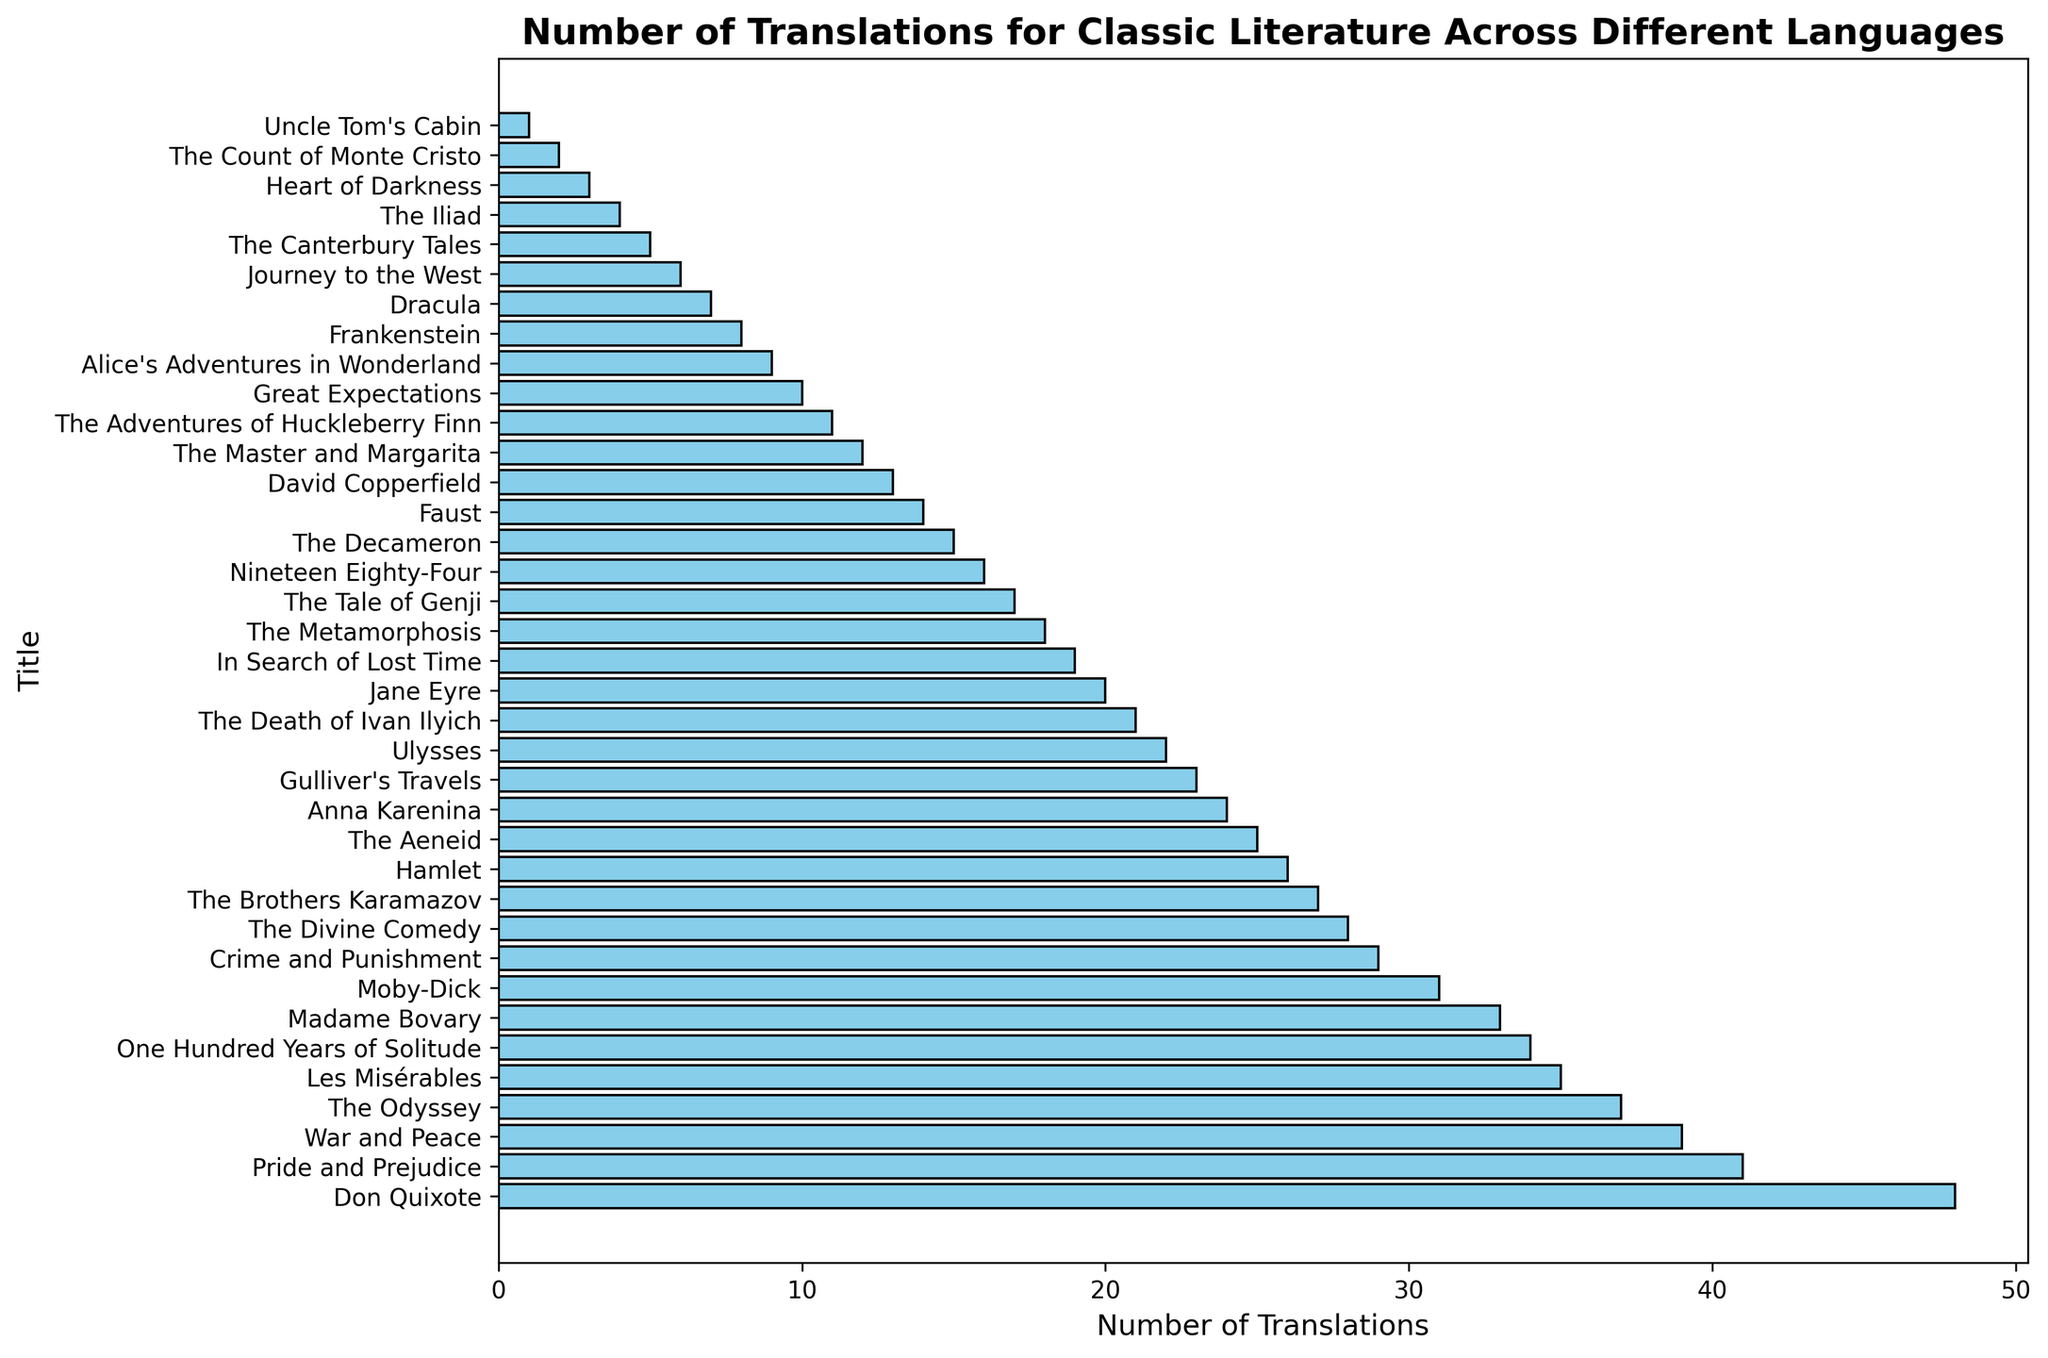What is the title with the highest number of translations? Identify the bar with the greatest length, as it represents the highest quantity. This bar corresponds to "Don Quixote".
Answer: "Don Quixote" Which language has the most titles translated more than 30 times? Check the languages of titles that appear on the top part of the histogram. Spanish has "Don Quixote" and "One Hundred Years of Solitude", while English has "Pride and Prejudice" and "Moby-Dick". Spanish and English each have two titles.
Answer: Spanish and English What is the total number of translations for the French titles in the dataset? Sum the number of translations for all French titles: "Les Misérables" (35), "Madame Bovary" (33), "In Search of Lost Time" (19), and "The Count of Monte Cristo" (2). 35 + 33 + 19 + 2 = 89
Answer: 89 Which two titles have a difference of exactly two translations between them? Examine the histogram for pairs of bars where the difference in length corresponds to a difference of two in translations. "The Odyssey" (37) and "Les Misérables" (35) match this criterion.
Answer: "The Odyssey" and "Les Misérables" How many titles have fewer than 10 translations? Count the number of bars that are shorter than the tick mark for 10 translations. Titles with fewer than 10 translations include "Journey to the West", "The Canterbury Tales", "The Iliad", "Heart of Darkness", "The Count of Monte Cristo", and "Uncle Tom's Cabin". There are 6 such titles.
Answer: 6 What is the average number of translations for English titles? Compute the average by summing the translations for English titles and dividing by the number of English titles: (41 + 31 + 26 + 23 + 22 + 20 + 16 + 13 + 11 + 10 + 9 + 8 + 7 + 5 + 3 + 1) / 16 = 13.875.
Answer: 13.875 Which title has the second highest number of translations? The second longest bar after "Don Quixote" represents the title with the second highest number of translations, which is "Pride and Prejudice" with 41 translations.
Answer: "Pride and Prejudice" Which language features the most frequently among the titles translated more than 20 times? Count the occurrence of each language among titles listed with more than 20 translations. English titles include "Pride and Prejudice" (41), "Moby-Dick" (31), "Hamlet" (26), "Gulliver's Travels" (23), and "Ulysses" (22) — totaling 5. Russian titles include "War and Peace" (39), "Crime and Punishment" (29), "The Brothers Karamazov" (27), and "Anna Karenina" (24) — totaling 4. Therefore, English is the most frequent.
Answer: English 